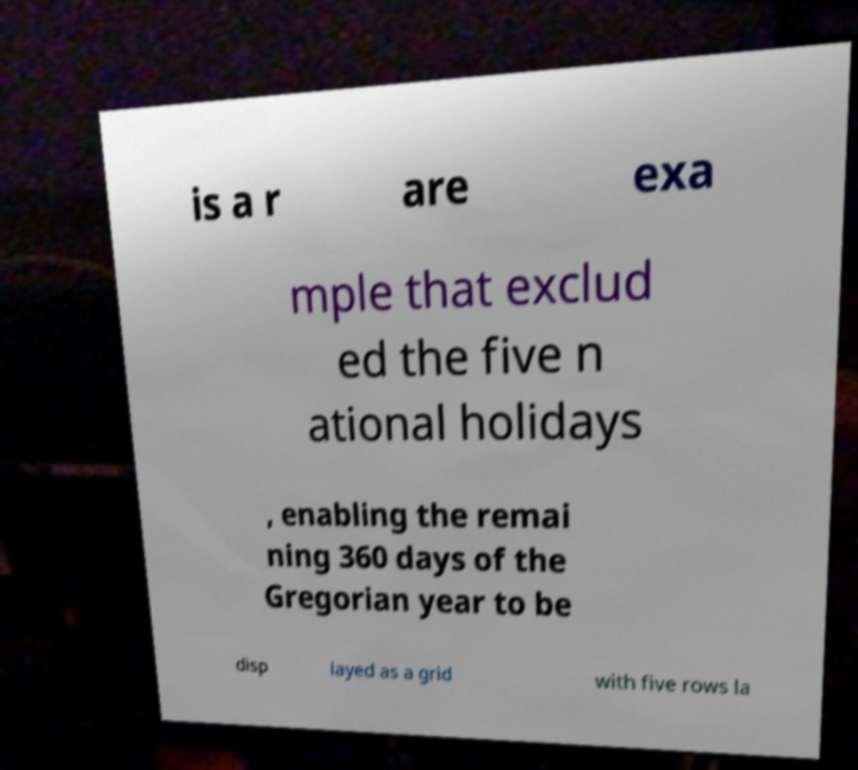What messages or text are displayed in this image? I need them in a readable, typed format. is a r are exa mple that exclud ed the five n ational holidays , enabling the remai ning 360 days of the Gregorian year to be disp layed as a grid with five rows la 